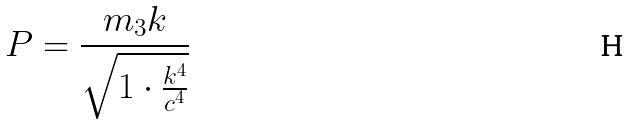Convert formula to latex. <formula><loc_0><loc_0><loc_500><loc_500>P = \frac { m _ { 3 } k } { \sqrt { 1 \cdot \frac { k ^ { 4 } } { c ^ { 4 } } } }</formula> 